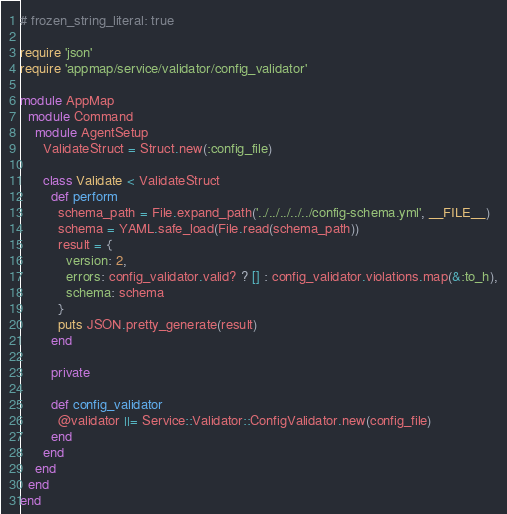Convert code to text. <code><loc_0><loc_0><loc_500><loc_500><_Ruby_># frozen_string_literal: true

require 'json'
require 'appmap/service/validator/config_validator'

module AppMap
  module Command
    module AgentSetup
      ValidateStruct = Struct.new(:config_file)

      class Validate < ValidateStruct
        def perform
          schema_path = File.expand_path('../../../../../config-schema.yml', __FILE__)
          schema = YAML.safe_load(File.read(schema_path))
          result = {
            version: 2,
            errors: config_validator.valid? ? [] : config_validator.violations.map(&:to_h),
            schema: schema
          }
          puts JSON.pretty_generate(result)
        end

        private

        def config_validator
          @validator ||= Service::Validator::ConfigValidator.new(config_file)
        end
      end
    end
  end
end
</code> 